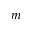Convert formula to latex. <formula><loc_0><loc_0><loc_500><loc_500>m</formula> 